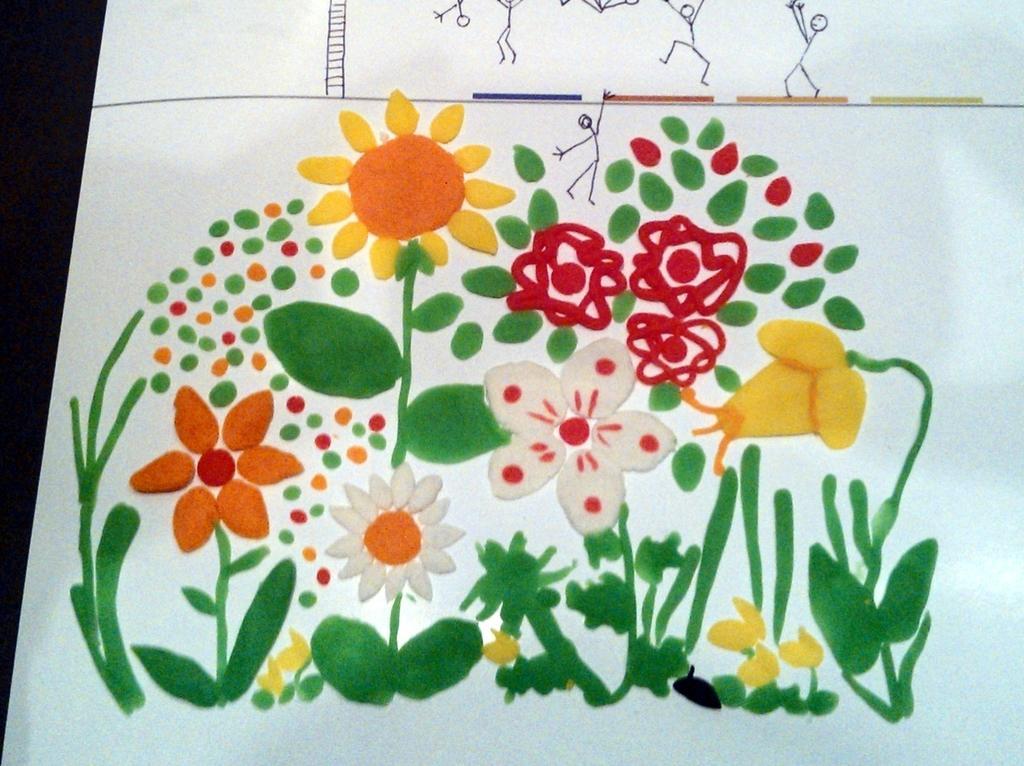In one or two sentences, can you explain what this image depicts? Here I can see a white color sheet which consists of some paintings of flowers and leaves. 